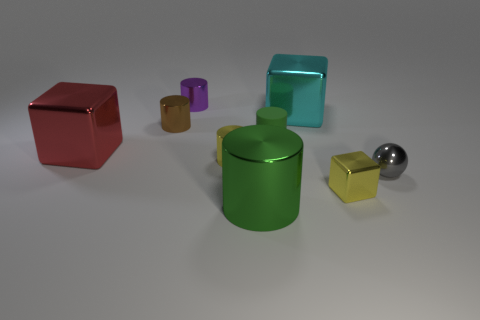Subtract all purple cylinders. How many cylinders are left? 4 Subtract 1 cylinders. How many cylinders are left? 4 Subtract all small yellow cylinders. How many cylinders are left? 4 Subtract all blue cylinders. Subtract all gray balls. How many cylinders are left? 5 Add 1 purple rubber things. How many objects exist? 10 Subtract all cubes. How many objects are left? 6 Add 8 gray shiny things. How many gray shiny things are left? 9 Add 6 red things. How many red things exist? 7 Subtract 1 red cubes. How many objects are left? 8 Subtract all yellow things. Subtract all tiny gray metal spheres. How many objects are left? 6 